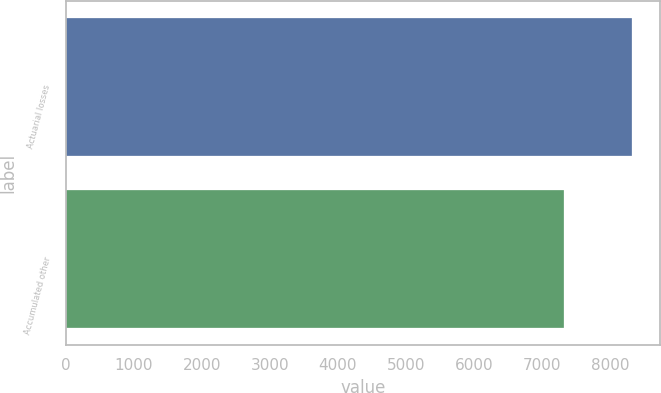<chart> <loc_0><loc_0><loc_500><loc_500><bar_chart><fcel>Actuarial losses<fcel>Accumulated other<nl><fcel>8321<fcel>7321<nl></chart> 